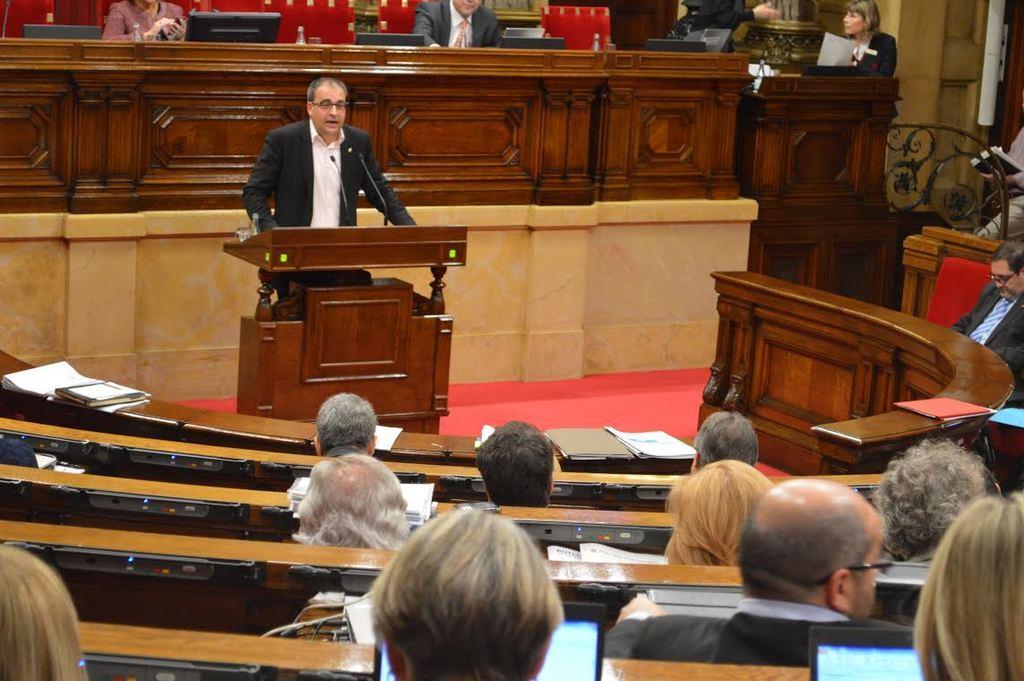Could you give a brief overview of what you see in this image? This image is taken into a conference room. In this image there is a person standing in front of the table and there is a mic on the table, around the person there are a few people sitting in their seats, in front of them there are papers, books and some other objects. 